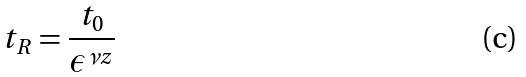Convert formula to latex. <formula><loc_0><loc_0><loc_500><loc_500>t _ { R } = \frac { t _ { 0 } } { \epsilon ^ { \nu z } }</formula> 